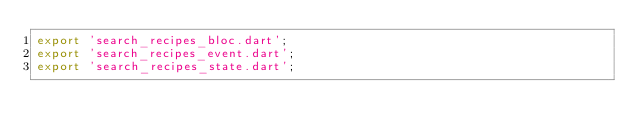<code> <loc_0><loc_0><loc_500><loc_500><_Dart_>export 'search_recipes_bloc.dart';
export 'search_recipes_event.dart';
export 'search_recipes_state.dart';
</code> 